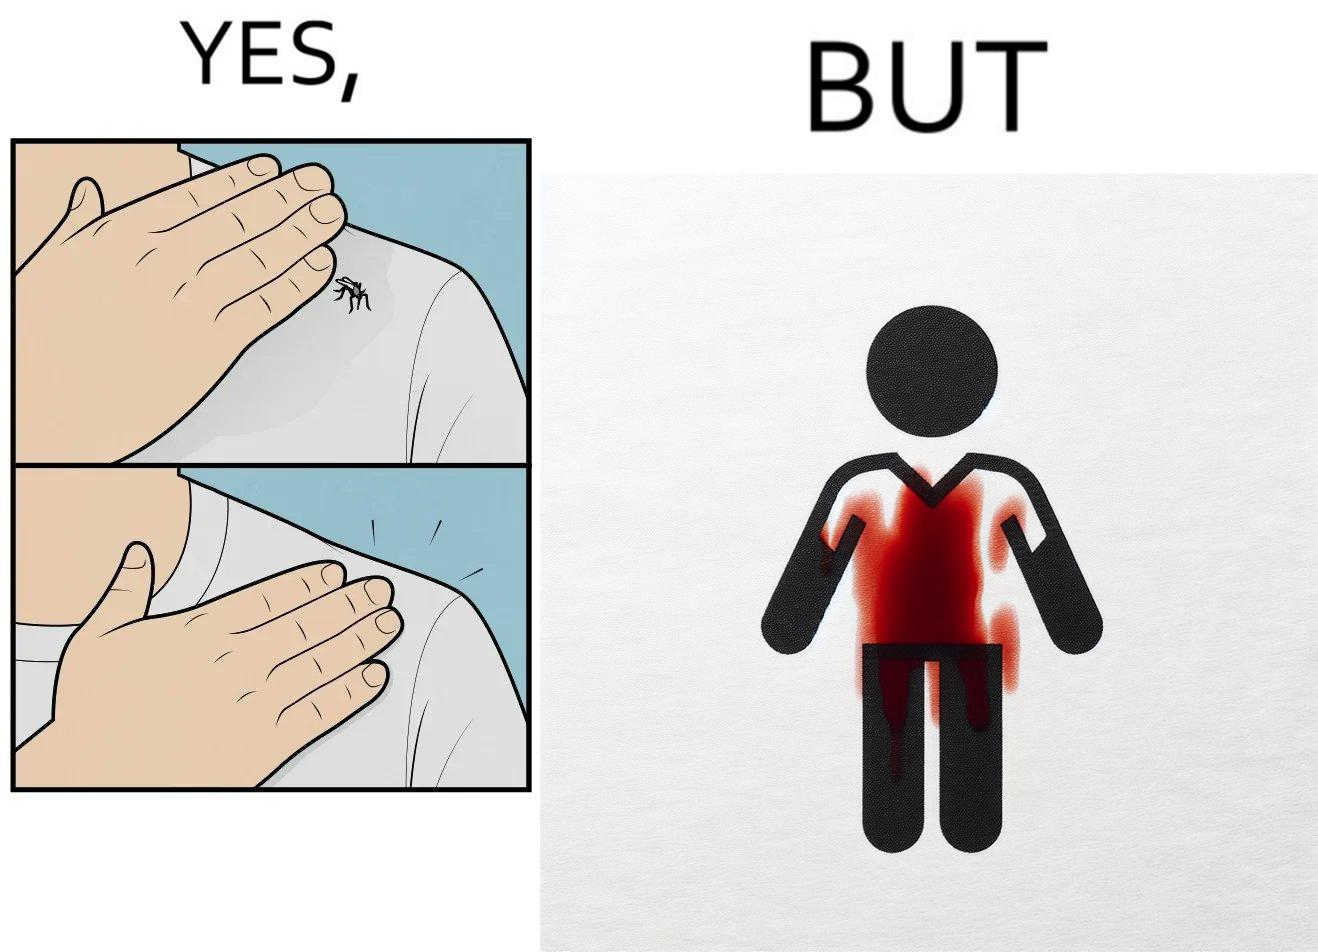What is the satirical meaning behind this image? The images are funny since a man trying to reduce his irritation by killing a mosquito bothering  him only causes himself more irritation by soiling his t-shirt with the mosquito blood 